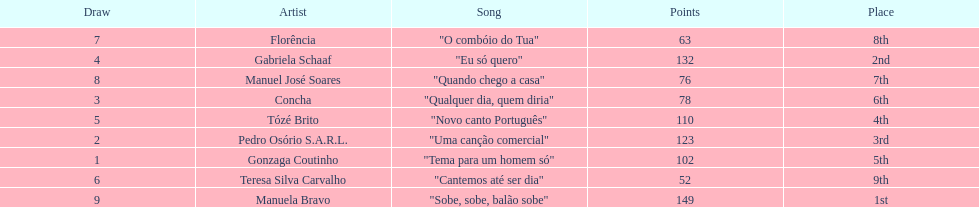Which artist came in last place? Teresa Silva Carvalho. 